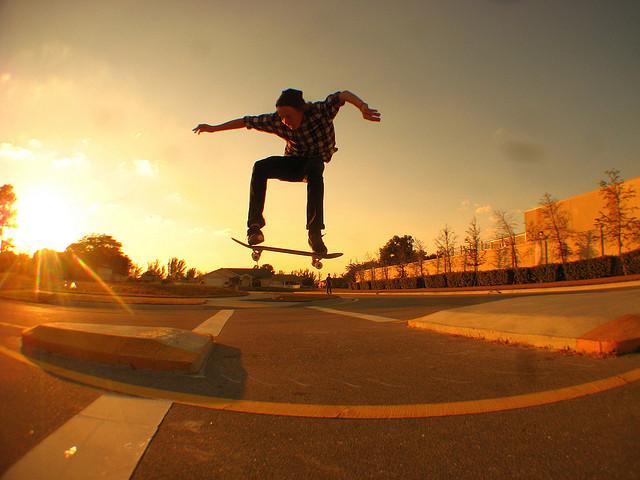What is the man doing tricks on?
Keep it brief. Skateboard. What is the bright object in the background?
Answer briefly. Sun. What pattern is his shirt?
Quick response, please. Plaid. What kind of clothing is this person wearing on his/her legs?
Short answer required. Jeans. What kind of trees are in the background?
Write a very short answer. Maple. How many people in the picture?
Short answer required. 1. 